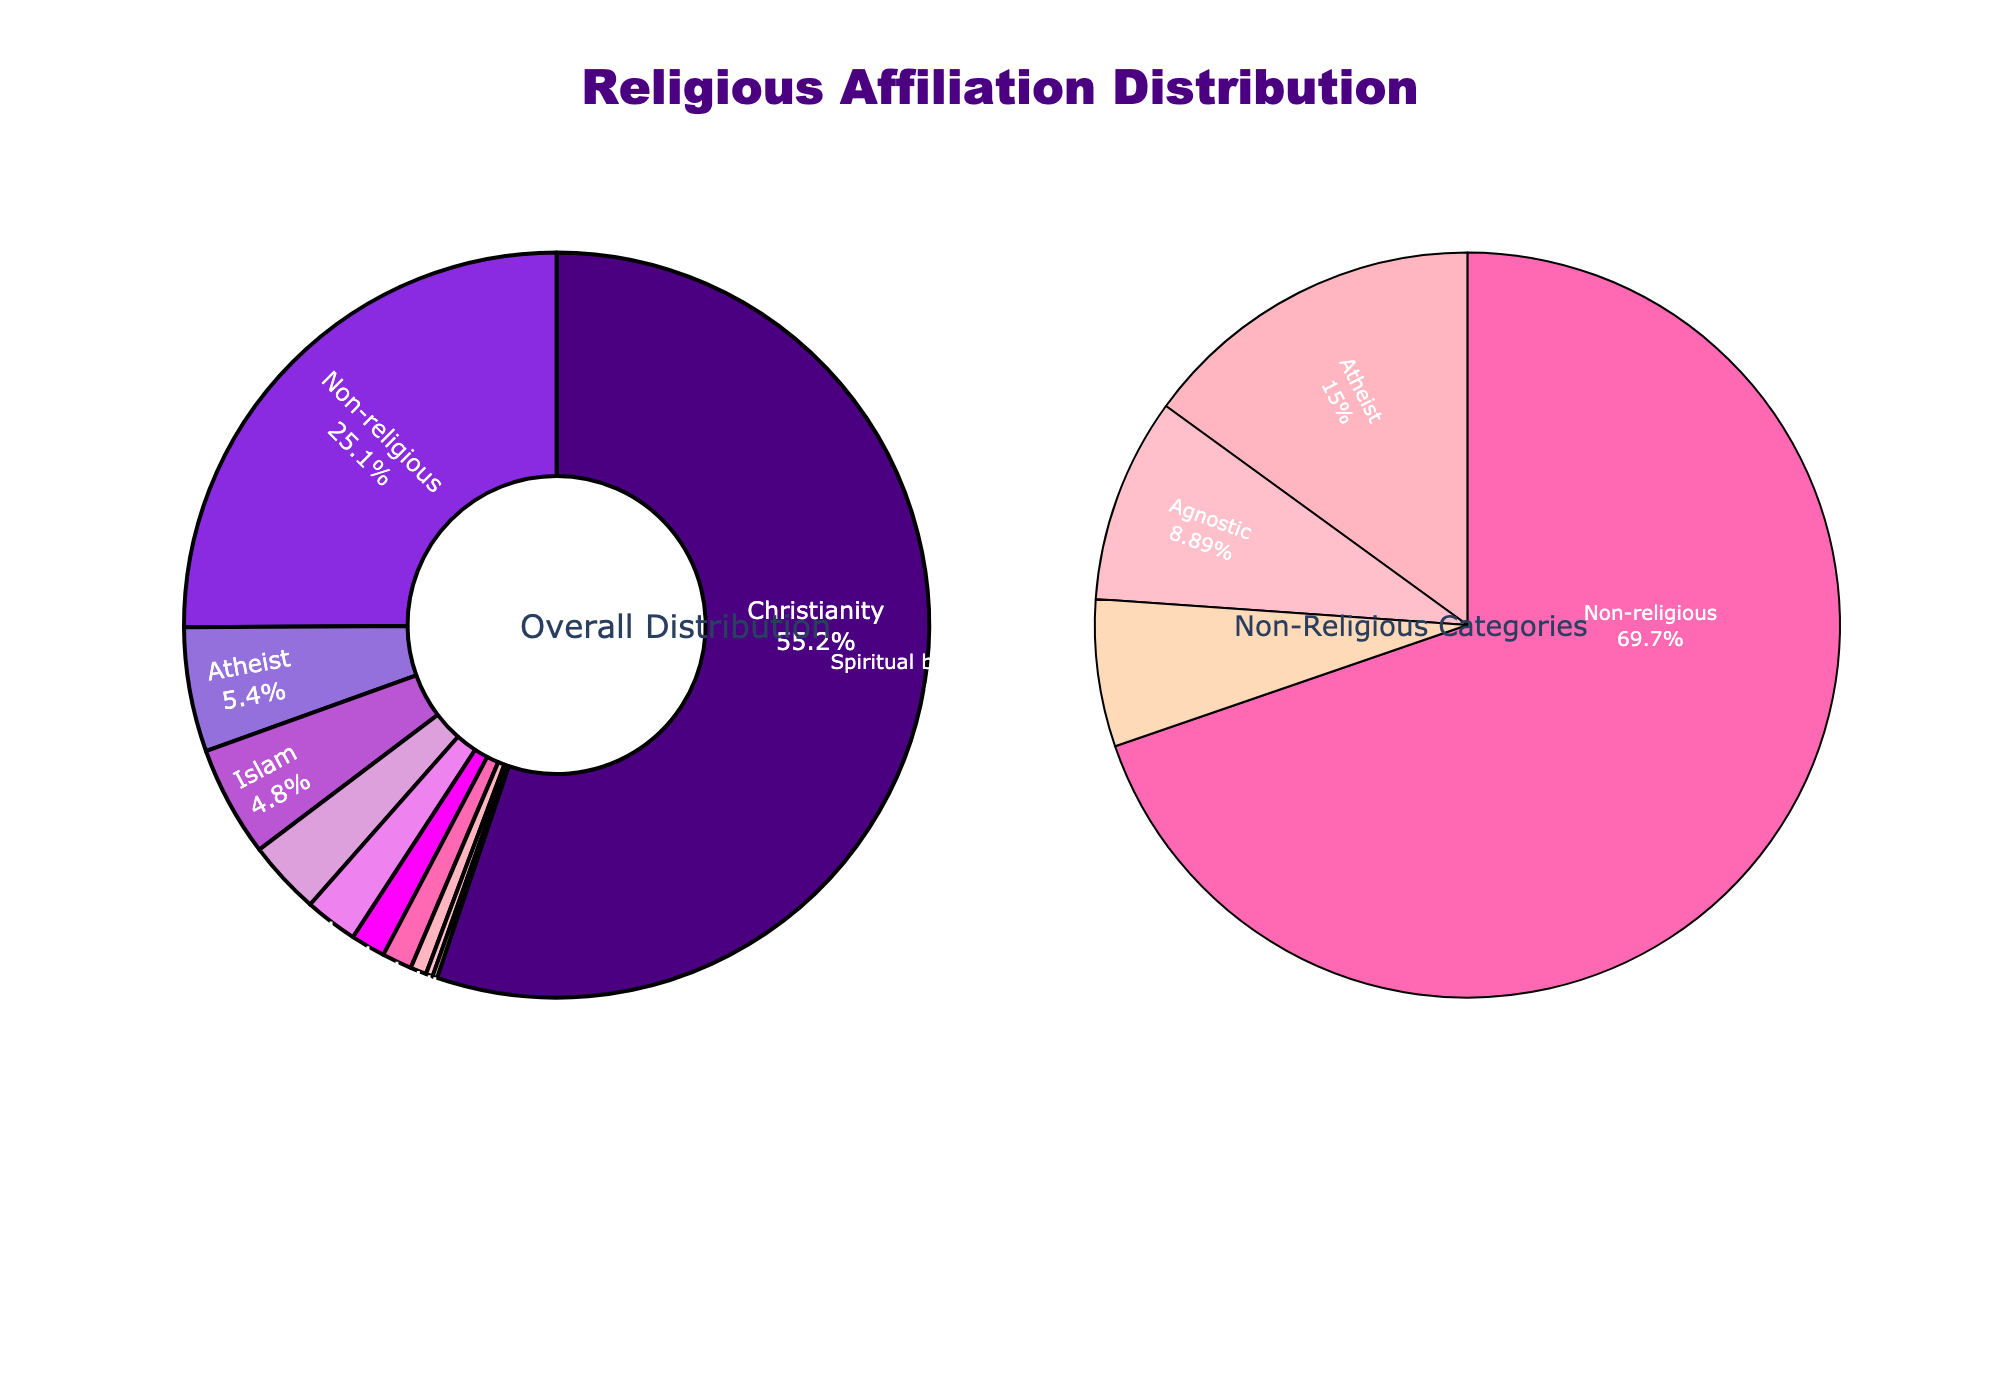What percentage of the population is either Christian or Muslim? To find the combined percentage of Christians and Muslims, add the percentage of Christianity (55.2) and Islam (4.8). So, 55.2 + 4.8 = 60.
Answer: 60 How does the percentage of non-religious people compare to atheists? Look at the two segments labeled "Non-religious" and "Atheist" in the pie chart. The "Non-religious" percentage is 25.1, and the "Atheist" percentage is 5.4. Non-religious is greater than atheist.
Answer: Non-religious is greater Which religious affiliation has the smallest percentage, and what is it? Look for the segment with the smallest percentage. The smallest segment is Judaism with 0.2%.
Answer: Judaism, 0.2% Is the sum of Hinduism and Buddhism greater than the percentage of Spiritual but not religious? Look at the percentages: Hinduism (1.5) and Buddhism (0.7). Sum them to get 1.5 + 0.7 = 2.2%. The "Spiritual but not religious" percentage is 2.3%. 2.2% is less than 2.3%.
Answer: No What is the combined percentage of people who are non-religious, atheist, and agnostic? Sum the percentages for "Non-religious" (25.1), "Atheist" (5.4), and "Agnostic" (3.2). 25.1 + 5.4 + 3.2 = 33.7.
Answer: 33.7 Which category has the highest percentage, and what is the percentage? Look for the segment with the largest percentage. Christianity is the largest segment with 55.2%.
Answer: Christianity, 55.2% By how much does the percentage of non-religious people exceed the percentage of all other religions combined? Add the percentages of all the other religions (Islam, Hinduism, Buddhism, Sikhism, Judaism, Other religions): 4.8 + 1.5 + 0.7 + 0.3 + 0.2 + 1.3 = 8.8%. The "Non-religious" percentage is 25.1%. Subtract 8.8 from 25.1 to get 25.1 - 8.8 = 16.3.
Answer: 16.3 Are there more atheists or agnostics? Look at the two segments labeled "Atheist" and "Agnostic". The "Atheist" percentage is 5.4 and the "Agnostic" percentage is 3.2. Atheists are greater.
Answer: Atheists What is the percentage difference between Christianity and all non-religious categories combined? Sum the percentages for all non-religious categories (Non-religious, Atheist, Agnostic, Spiritual but not religious): 25.1 + 5.4 + 3.2 + 2.3 = 36. The percentage of Christianity is 55.2. Subtract 36 from 55.2 to get 55.2 - 36 = 19.2.
Answer: 19.2 Adding up all the religion categories excluding non-religious categories, what is the total percentage? Add the percentages except for non-religious categories: Christianity (55.2), Islam (4.8), Hinduism (1.5), Buddhism (0.7), Sikhism (0.3), Judaism (0.2), and Other religions (1.3). So 55.2 + 4.8 + 1.5 + 0.7 + 0.3 + 0.2 + 1.3 = 64.
Answer: 64 